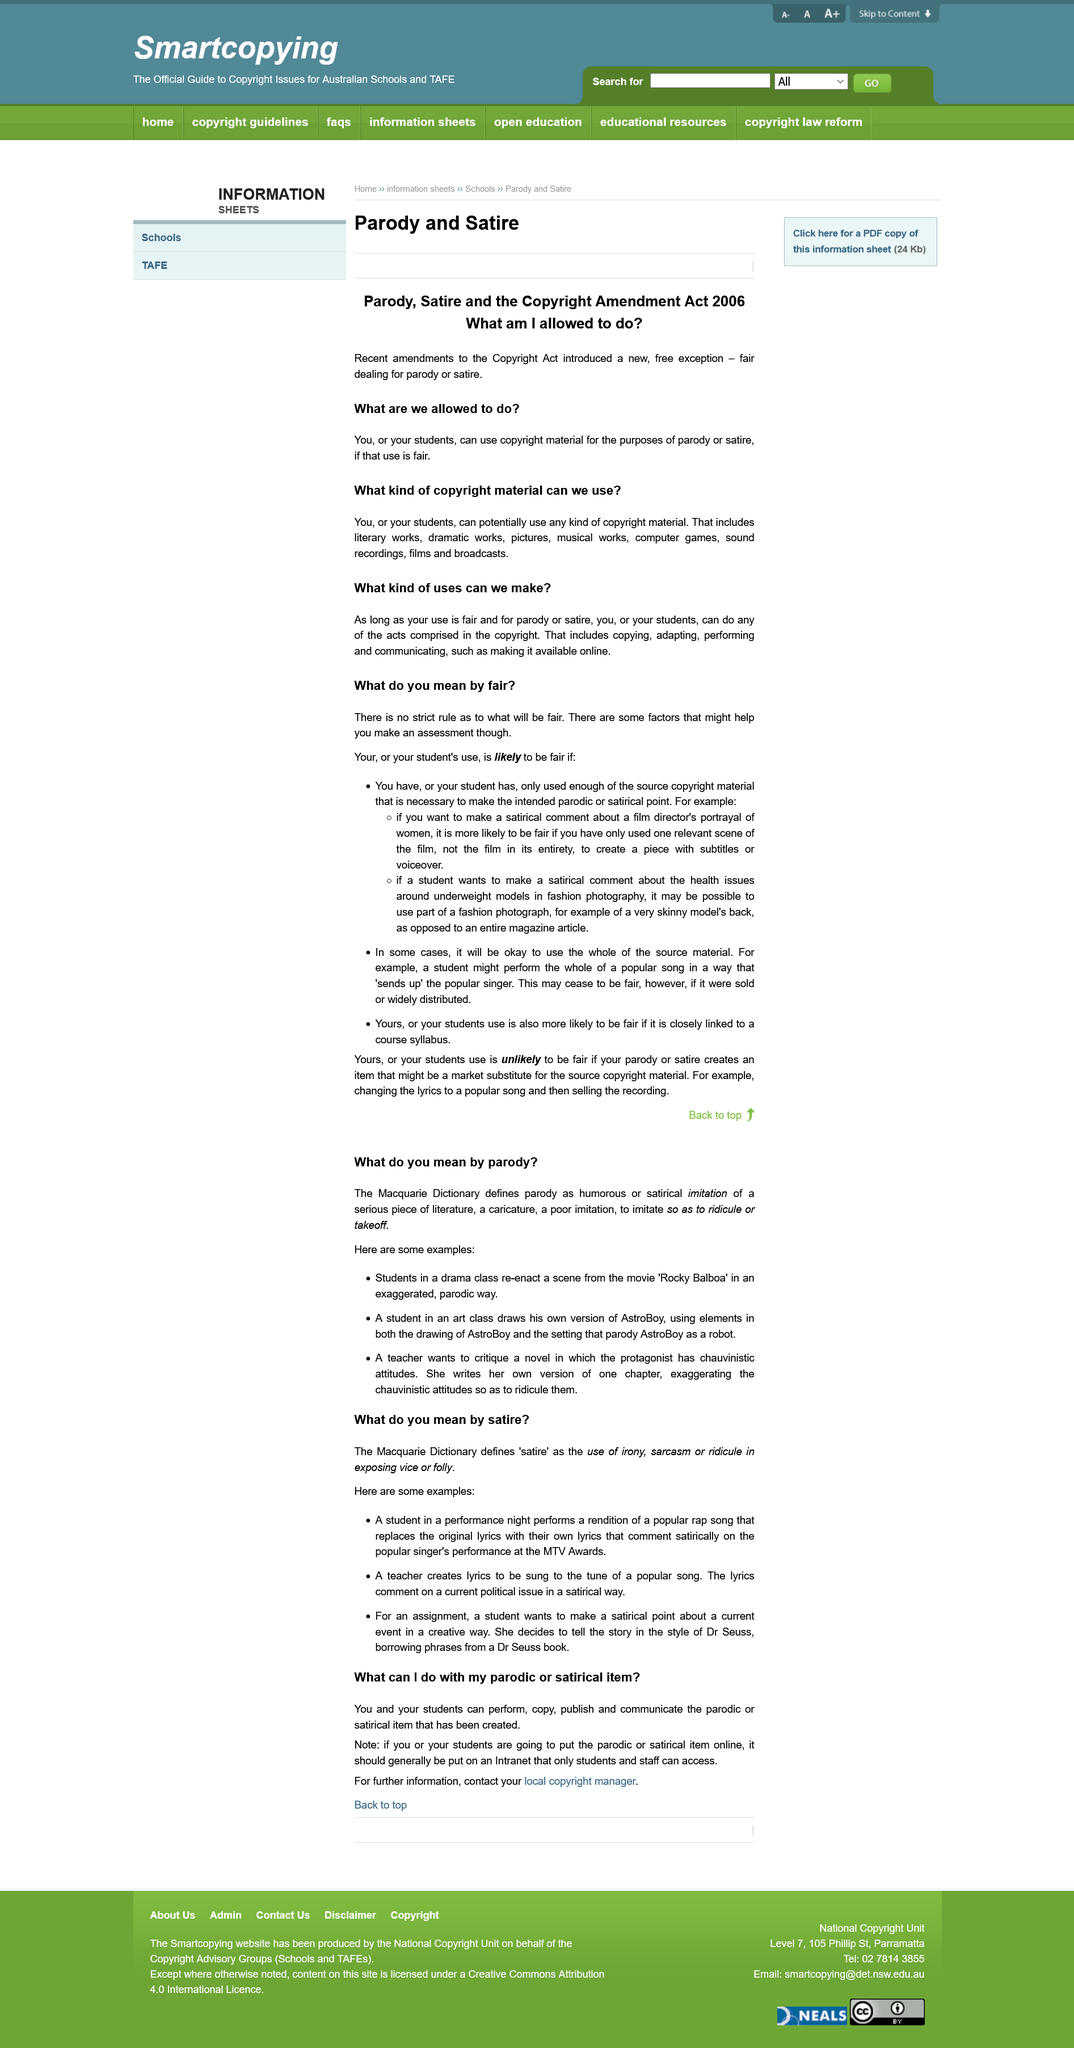Point out several critical features in this image. The individual responsible for copyright matters in your region should be contacted for additional information. It is not likely for a student's use of a work to be considered fair if they have used the entire film to make a satirical point, but it is more likely to be considered fair if they have only used one relevant scene," declares the law. Any copyright material, including literary works, dramatic works, pictures, musical works, computer games, sound recordings, films, and broadcasts can be used. A parodic item is another name for a satirical item. The Copyright Amendment Act 2006 allows students to use copyright material for the purposes of parody or satire, as long as the use is fair. 